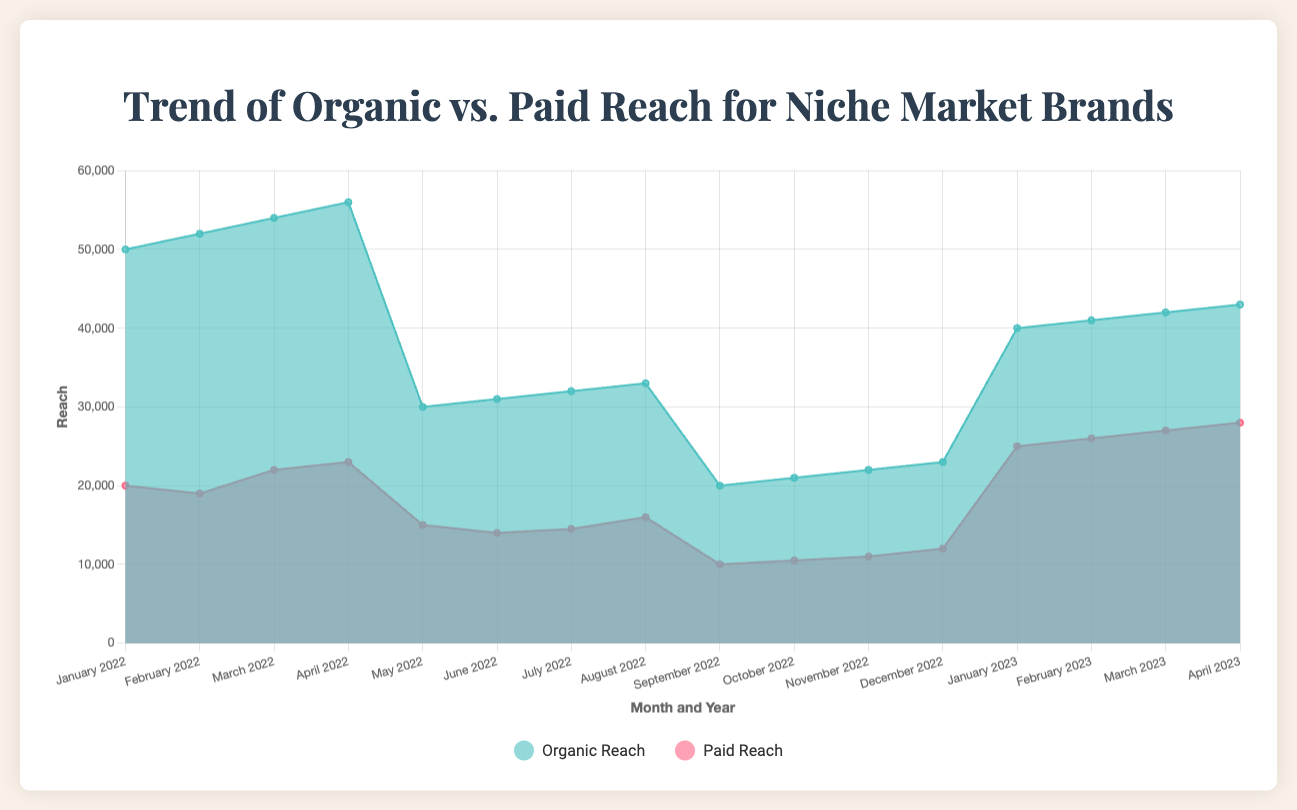What is the title of the chart? The title of the chart is prominently displayed at the top of the chart in larger font.
Answer: Trend of Organic vs. Paid Reach for Niche Market Brands What do the different colors in the chart represent? The chart legend indicates that the different colors represent Organic Reach (greenish color) and Paid Reach (reddish color).
Answer: Organic (greenish), Paid (reddish) What's the highest organic reach recorded in the chart, and in which month/year? The highest organic reach is represented by the highest point in the greenish area of the chart, corresponding to the month/year.
Answer: 56,000 (April 2022) Which brand had the lowest paid reach and in which month/year? The lowest paid reach appears as the lowest point in the reddish area of the chart and corresponds to the specific month/year.
Answer: Gucci (June 2022) What is the trend of organic reach for Tesla across the four months displayed? By looking at the sequential monthly data points for Tesla in the greenish area of the chart, the trend indicates an increase.
Answer: Increasing How does the organic reach of Louis Vuitton in April 2023 compare to its paid reach in the same month? Identify the values for both organic and paid reach for Louis Vuitton in April 2023 and compare them directly.
Answer: Organic Reach is less than Paid Reach (43,000 vs. 28,000) Between Gucci and Rolex, which brand saw a higher increase in paid reach from their respective starting to ending months within the period? Calculating the difference in paid reach for both brands from their starting to ending months and comparing the increases.
Answer: Gucci had a higher increase (1,500 vs. 2,000) What's the overall trend of paid reach across all brands in the available data? Summarize the patterns observed in the reddish areas across the chart for all the brands cumulatively.
Answer: Generally increasing What is the average organic reach for Tesla from January to April 2022? Sum the organic reach values for Tesla from January to April 2022 and divide by the number of months (4). (50,000 + 52,000 + 54,000 + 56,000) / 4 = 53,000
Answer: 53,000 What is the difference between the highest organic reach and the highest paid reach? Identify the highest values for both organic and paid reach and subtract the paid reach from the organic reach. 56,000 - 28,000
Answer: 28,000 